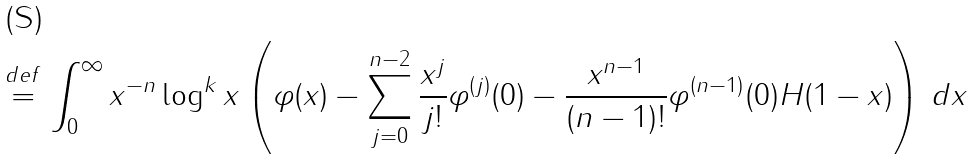Convert formula to latex. <formula><loc_0><loc_0><loc_500><loc_500>\stackrel { d e f } { = } \int _ { 0 } ^ { \infty } x ^ { - n } \log ^ { k } x \left ( \varphi ( x ) - \sum _ { j = 0 } ^ { n - 2 } \frac { x ^ { j } } { j ! } \varphi ^ { ( j ) } ( 0 ) - \frac { x ^ { n - 1 } } { ( n - 1 ) ! } \varphi ^ { ( n - 1 ) } ( 0 ) H ( 1 - x ) \right ) \, d x</formula> 